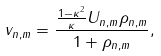<formula> <loc_0><loc_0><loc_500><loc_500>v _ { n , m } = \frac { \frac { 1 - \kappa ^ { 2 } } { \kappa } U _ { n , m } \rho _ { n , m } } { 1 + \rho _ { n , m } } ,</formula> 